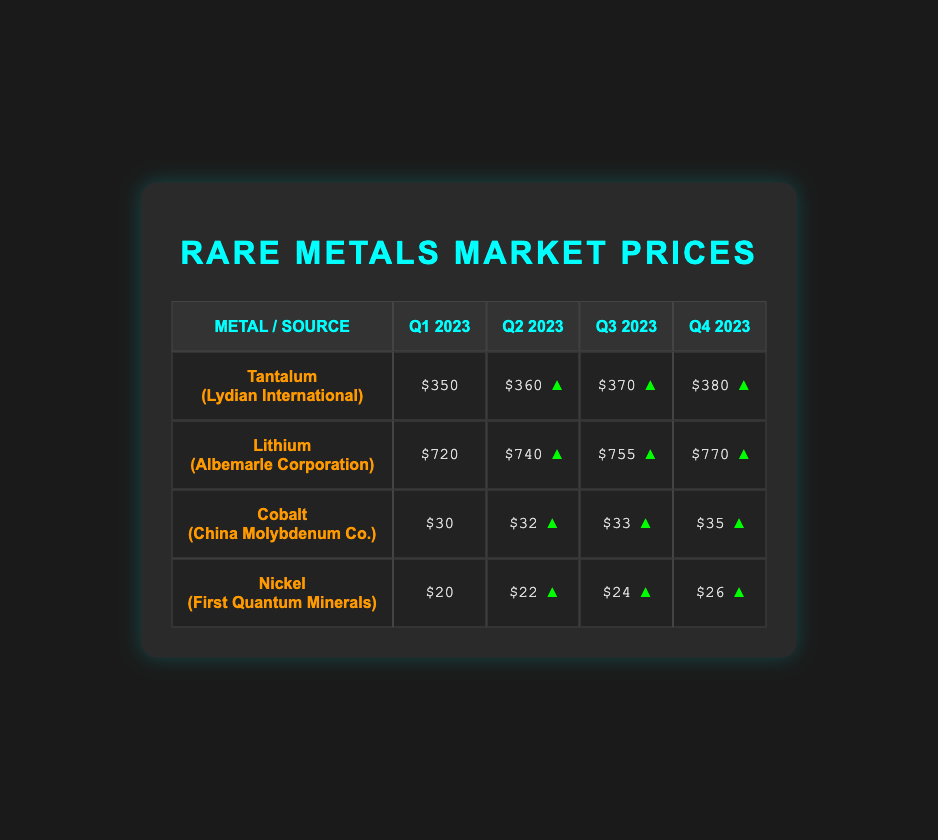What is the price of Tantalum from Lydian International in Q3 2023? The table shows that the price of Tantalum from Lydian International in Q3 2023 is $370.
Answer: $370 Which source had the highest price for Lithium in Q4 2023? The table shows that Albemarle Corporation had the highest price for Lithium in Q4 2023 at $770.
Answer: Albemarle Corporation Is the price of Nickel from First Quantum Minerals increasing, decreasing, or stable from Q1 2023 to Q4 2023? The prices for Nickel from First Quantum Minerals are $20 in Q1, $22 in Q2, $24 in Q3, and $26 in Q4, indicating a consistent increase over the four quarters.
Answer: Increasing What is the total price increase for Cobalt from Q1 to Q4 2023? The price of Cobalt is $30 in Q1 and $35 in Q4. The increase is calculated as $35 - $30 = $5.
Answer: $5 Was the price of Lithium higher than $700 during any quarter? Yes, the prices for Lithium in Q2, Q3, and Q4 2023 were $740, $755, and $770, respectively, all exceeding $700.
Answer: Yes What is the average price of Tantalum across all quarters? To find the average price of Tantalum: (350 + 360 + 370 + 380) = 1460; Then, divide the sum by 4, which gives 1460/4 = 365.
Answer: $365 Which metal had the lowest average price across all quarters? First, calculate the average prices: Tantalum: $365, Lithium: $765, Cobalt: $32.5, Nickel: $23. This shows that Cobalt has the lowest average price, being $32.5.
Answer: Cobalt What is the price difference between Tantalum in Q1 and Q4 2023? The price of Tantalum in Q4 2023 is $380 and in Q1 2023 is $350. The difference is $380 - $350 = $30.
Answer: $30 Did the price of Cobalt increase every quarter? The prices of Cobalt increased from $30 in Q1 to $32 in Q2, $33 in Q3, and $35 in Q4, indicating an increase each quarter.
Answer: Yes 